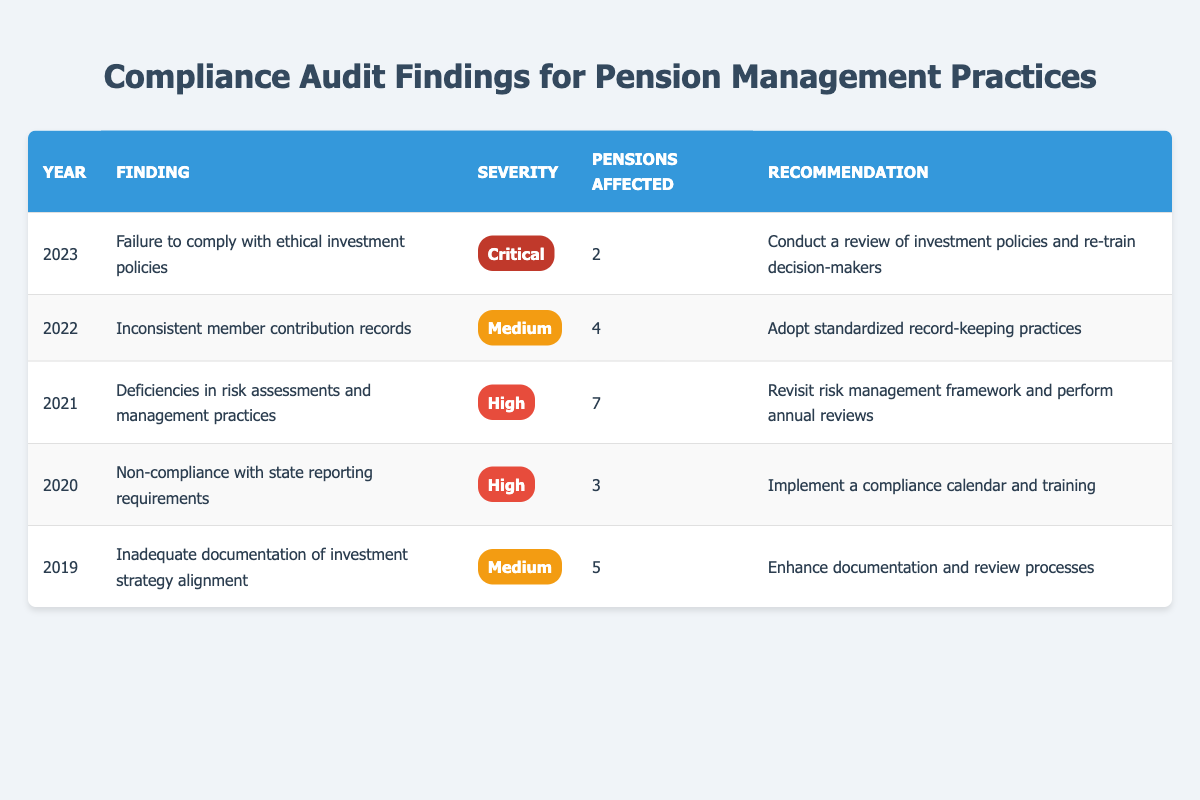What finding had the highest severity level in 2023? The table shows that the finding in 2023 was "Failure to comply with ethical investment policies," which is categorized as "Critical."
Answer: Critical How many pensions were affected by non-compliance with state reporting requirements in 2020? Referring to the table, the finding for 2020 indicates that 3 pensions were affected by the issue of non-compliance with state reporting requirements.
Answer: 3 What is the average number of pensions affected across all findings from 2019 to 2023? Adding the number of pensions affected: 5 (2019) + 3 (2020) + 7 (2021) + 4 (2022) + 2 (2023) = 21. There are 5 findings, so the average is calculated as 21 divided by 5, which equals 4.2.
Answer: 4.2 Did any finding between 2019 and 2023 have a severity level categorized as Low? Referring to the table, all severity levels listed are Medium, High, or Critical. There is no mention of any finding being categorized as Low.
Answer: No Which year had the most pensions affected and what was the finding associated with it? Looking at the numbers in the table, 2021 had the highest number of pensions affected, which was 7. The finding associated with that year was "Deficiencies in risk assessments and management practices."
Answer: 2021, Deficiencies in risk assessments and management practices What was the recommendation for addressing the finding related to inconsistent member contribution records in 2022? According to the table, the recommendation for addressing the finding in 2022, which was "Inconsistent member contribution records," was to "Adopt standardized record-keeping practices."
Answer: Adopt standardized record-keeping practices How many findings are classified as High severity from 2019 to 2023? The table lists two findings that are classified as High severity: one in 2020 and one in 2021, totaling two High severity findings.
Answer: 2 What finding needs a review of investment policies and retraining of decision-makers? The table indicates that the finding for 2023, "Failure to comply with ethical investment policies," requires a review of investment policies and retraining of decision-makers.
Answer: Failure to comply with ethical investment policies 